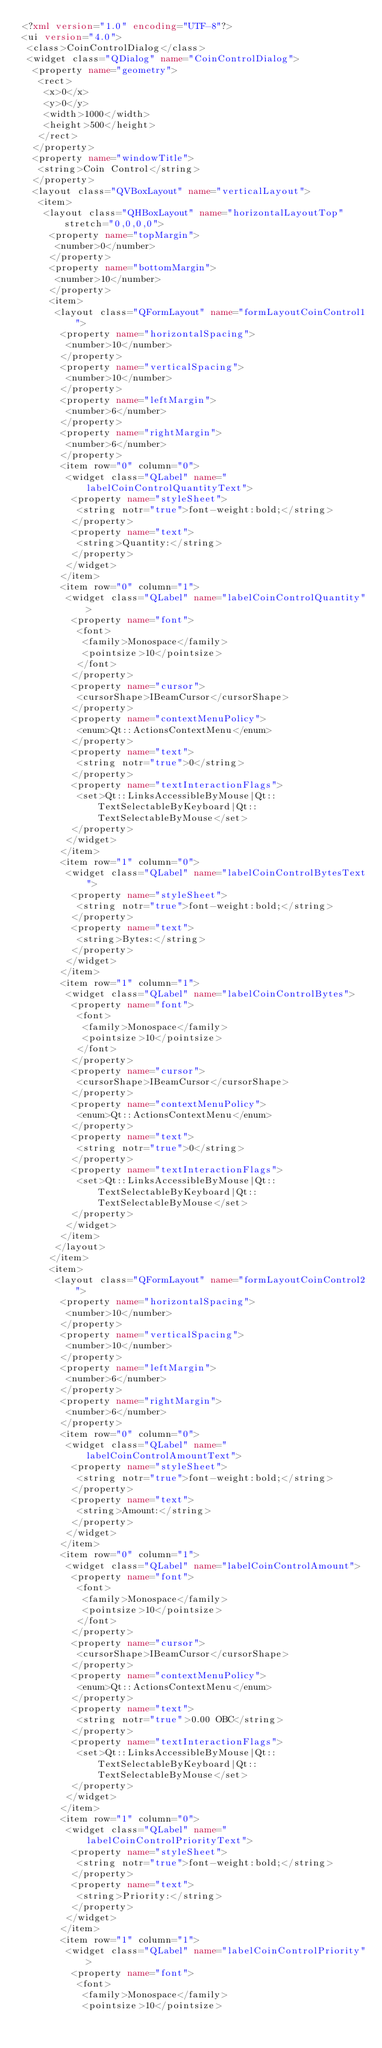<code> <loc_0><loc_0><loc_500><loc_500><_XML_><?xml version="1.0" encoding="UTF-8"?>
<ui version="4.0">
 <class>CoinControlDialog</class>
 <widget class="QDialog" name="CoinControlDialog">
  <property name="geometry">
   <rect>
    <x>0</x>
    <y>0</y>
    <width>1000</width>
    <height>500</height>
   </rect>
  </property>
  <property name="windowTitle">
   <string>Coin Control</string>
  </property>
  <layout class="QVBoxLayout" name="verticalLayout">
   <item>
    <layout class="QHBoxLayout" name="horizontalLayoutTop" stretch="0,0,0,0">
     <property name="topMargin">
      <number>0</number>
     </property>
     <property name="bottomMargin">
      <number>10</number>
     </property>
     <item>
      <layout class="QFormLayout" name="formLayoutCoinControl1">
       <property name="horizontalSpacing">
        <number>10</number>
       </property>
       <property name="verticalSpacing">
        <number>10</number>
       </property>
       <property name="leftMargin">
        <number>6</number>
       </property>
       <property name="rightMargin">
        <number>6</number>
       </property>
       <item row="0" column="0">
        <widget class="QLabel" name="labelCoinControlQuantityText">
         <property name="styleSheet">
          <string notr="true">font-weight:bold;</string>
         </property>
         <property name="text">
          <string>Quantity:</string>
         </property>
        </widget>
       </item>
       <item row="0" column="1">
        <widget class="QLabel" name="labelCoinControlQuantity">
         <property name="font">
          <font>
           <family>Monospace</family>
           <pointsize>10</pointsize>
          </font>
         </property>
         <property name="cursor">
          <cursorShape>IBeamCursor</cursorShape>
         </property>
         <property name="contextMenuPolicy">
          <enum>Qt::ActionsContextMenu</enum>
         </property>
         <property name="text">
          <string notr="true">0</string>
         </property>
         <property name="textInteractionFlags">
          <set>Qt::LinksAccessibleByMouse|Qt::TextSelectableByKeyboard|Qt::TextSelectableByMouse</set>
         </property>
        </widget>
       </item>
       <item row="1" column="0">
        <widget class="QLabel" name="labelCoinControlBytesText">
         <property name="styleSheet">
          <string notr="true">font-weight:bold;</string>
         </property>
         <property name="text">
          <string>Bytes:</string>
         </property>
        </widget>
       </item>
       <item row="1" column="1">
        <widget class="QLabel" name="labelCoinControlBytes">
         <property name="font">
          <font>
           <family>Monospace</family>
           <pointsize>10</pointsize>
          </font>
         </property>
         <property name="cursor">
          <cursorShape>IBeamCursor</cursorShape>
         </property>
         <property name="contextMenuPolicy">
          <enum>Qt::ActionsContextMenu</enum>
         </property>
         <property name="text">
          <string notr="true">0</string>
         </property>
         <property name="textInteractionFlags">
          <set>Qt::LinksAccessibleByMouse|Qt::TextSelectableByKeyboard|Qt::TextSelectableByMouse</set>
         </property>
        </widget>
       </item>
      </layout>
     </item>
     <item>
      <layout class="QFormLayout" name="formLayoutCoinControl2">
       <property name="horizontalSpacing">
        <number>10</number>
       </property>
       <property name="verticalSpacing">
        <number>10</number>
       </property>
       <property name="leftMargin">
        <number>6</number>
       </property>
       <property name="rightMargin">
        <number>6</number>
       </property>
       <item row="0" column="0">
        <widget class="QLabel" name="labelCoinControlAmountText">
         <property name="styleSheet">
          <string notr="true">font-weight:bold;</string>
         </property>
         <property name="text">
          <string>Amount:</string>
         </property>
        </widget>
       </item>
       <item row="0" column="1">
        <widget class="QLabel" name="labelCoinControlAmount">
         <property name="font">
          <font>
           <family>Monospace</family>
           <pointsize>10</pointsize>
          </font>
         </property>
         <property name="cursor">
          <cursorShape>IBeamCursor</cursorShape>
         </property>
         <property name="contextMenuPolicy">
          <enum>Qt::ActionsContextMenu</enum>
         </property>
         <property name="text">
          <string notr="true">0.00 OBC</string>
         </property>
         <property name="textInteractionFlags">
          <set>Qt::LinksAccessibleByMouse|Qt::TextSelectableByKeyboard|Qt::TextSelectableByMouse</set>
         </property>
        </widget>
       </item>
       <item row="1" column="0">
        <widget class="QLabel" name="labelCoinControlPriorityText">
         <property name="styleSheet">
          <string notr="true">font-weight:bold;</string>
         </property>
         <property name="text">
          <string>Priority:</string>
         </property>
        </widget>
       </item>
       <item row="1" column="1">
        <widget class="QLabel" name="labelCoinControlPriority">
         <property name="font">
          <font>
           <family>Monospace</family>
           <pointsize>10</pointsize></code> 